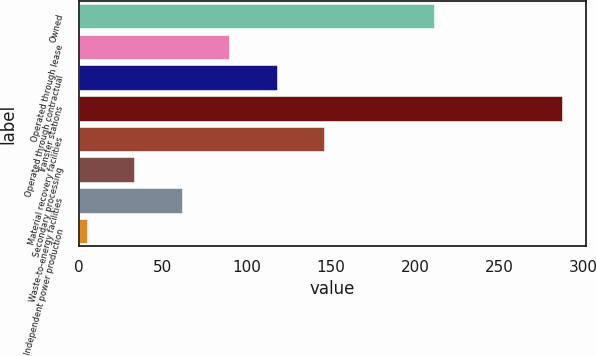Convert chart. <chart><loc_0><loc_0><loc_500><loc_500><bar_chart><fcel>Owned<fcel>Operated through lease<fcel>Operated through contractual<fcel>Transfer stations<fcel>Material recovery facilities<fcel>Secondary processing<fcel>Waste-to-energy facilities<fcel>Independent power production<nl><fcel>211<fcel>89.6<fcel>117.8<fcel>287<fcel>146<fcel>33.2<fcel>61.4<fcel>5<nl></chart> 